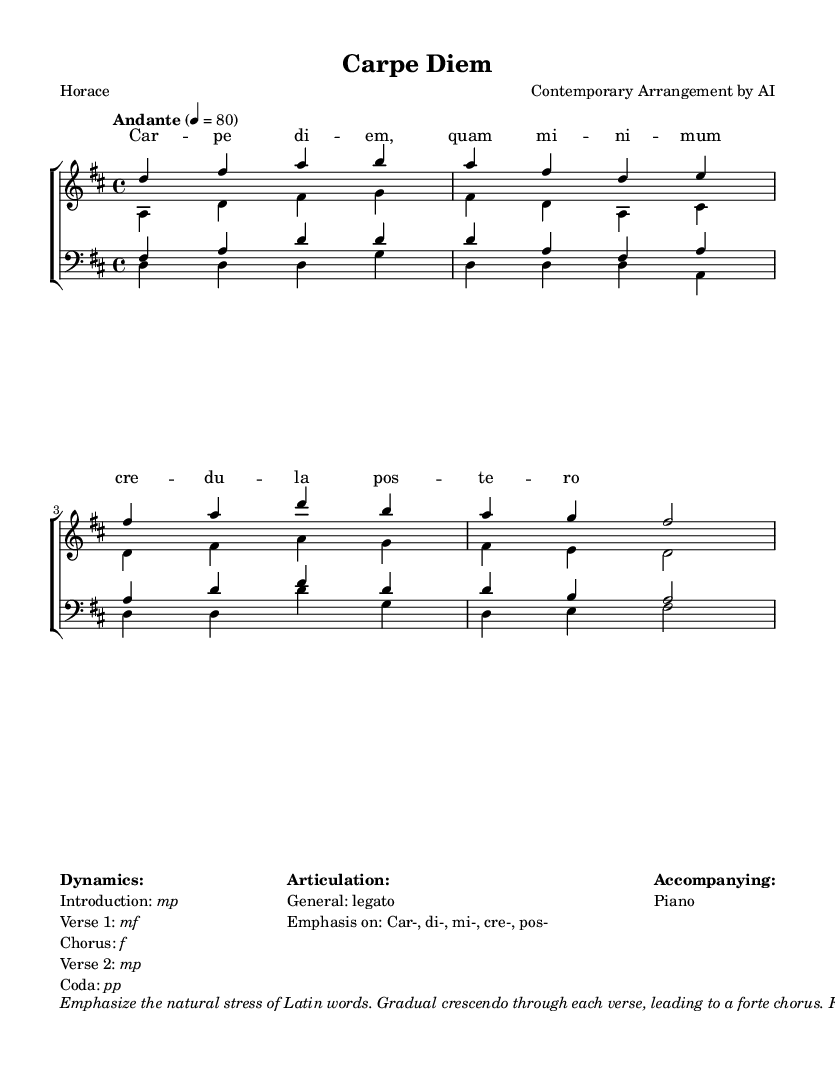What is the key signature of this music? The key signature is indicated at the beginning of the staff. In this case, there are two sharps present, which corresponds to D major.
Answer: D major What is the time signature of this music? The time signature appears at the beginning of the sheet music, and here it shows 4/4, meaning there are four beats per measure with a quarter note receiving one beat.
Answer: 4/4 What is the tempo marking for this piece? The tempo marking is indicated by the word "Andante" followed by a metronome marking of 80. This indicates a moderately slow tempo.
Answer: Andante How many voices are in this arrangement? By analyzing the score, there are two vocal parts for women (sopranos and altos) and two for men (tenors and basses), totaling four voices.
Answer: Four What dynamic should be emphasized in the introduction of this piece? The dynamics are specified in the markup. For the introduction, the dynamic marking is indicated as "mp," which means mezzo piano or moderately soft.
Answer: mp Which word should have an emphasis in the articulation? The markup includes a specific note on which syllables to emphasize, with "Car-", "di-", "mi-", "cre-", and "pos-" highlighted for emphasis.
Answer: Car-, di-, mi-, cre-, pos- What is the final dynamic instruction given for the coda? The final instruction in the markup specifies that the coda should end with a dynamic marking of "pp," which stands for pianissimo, meaning very soft.
Answer: pp 